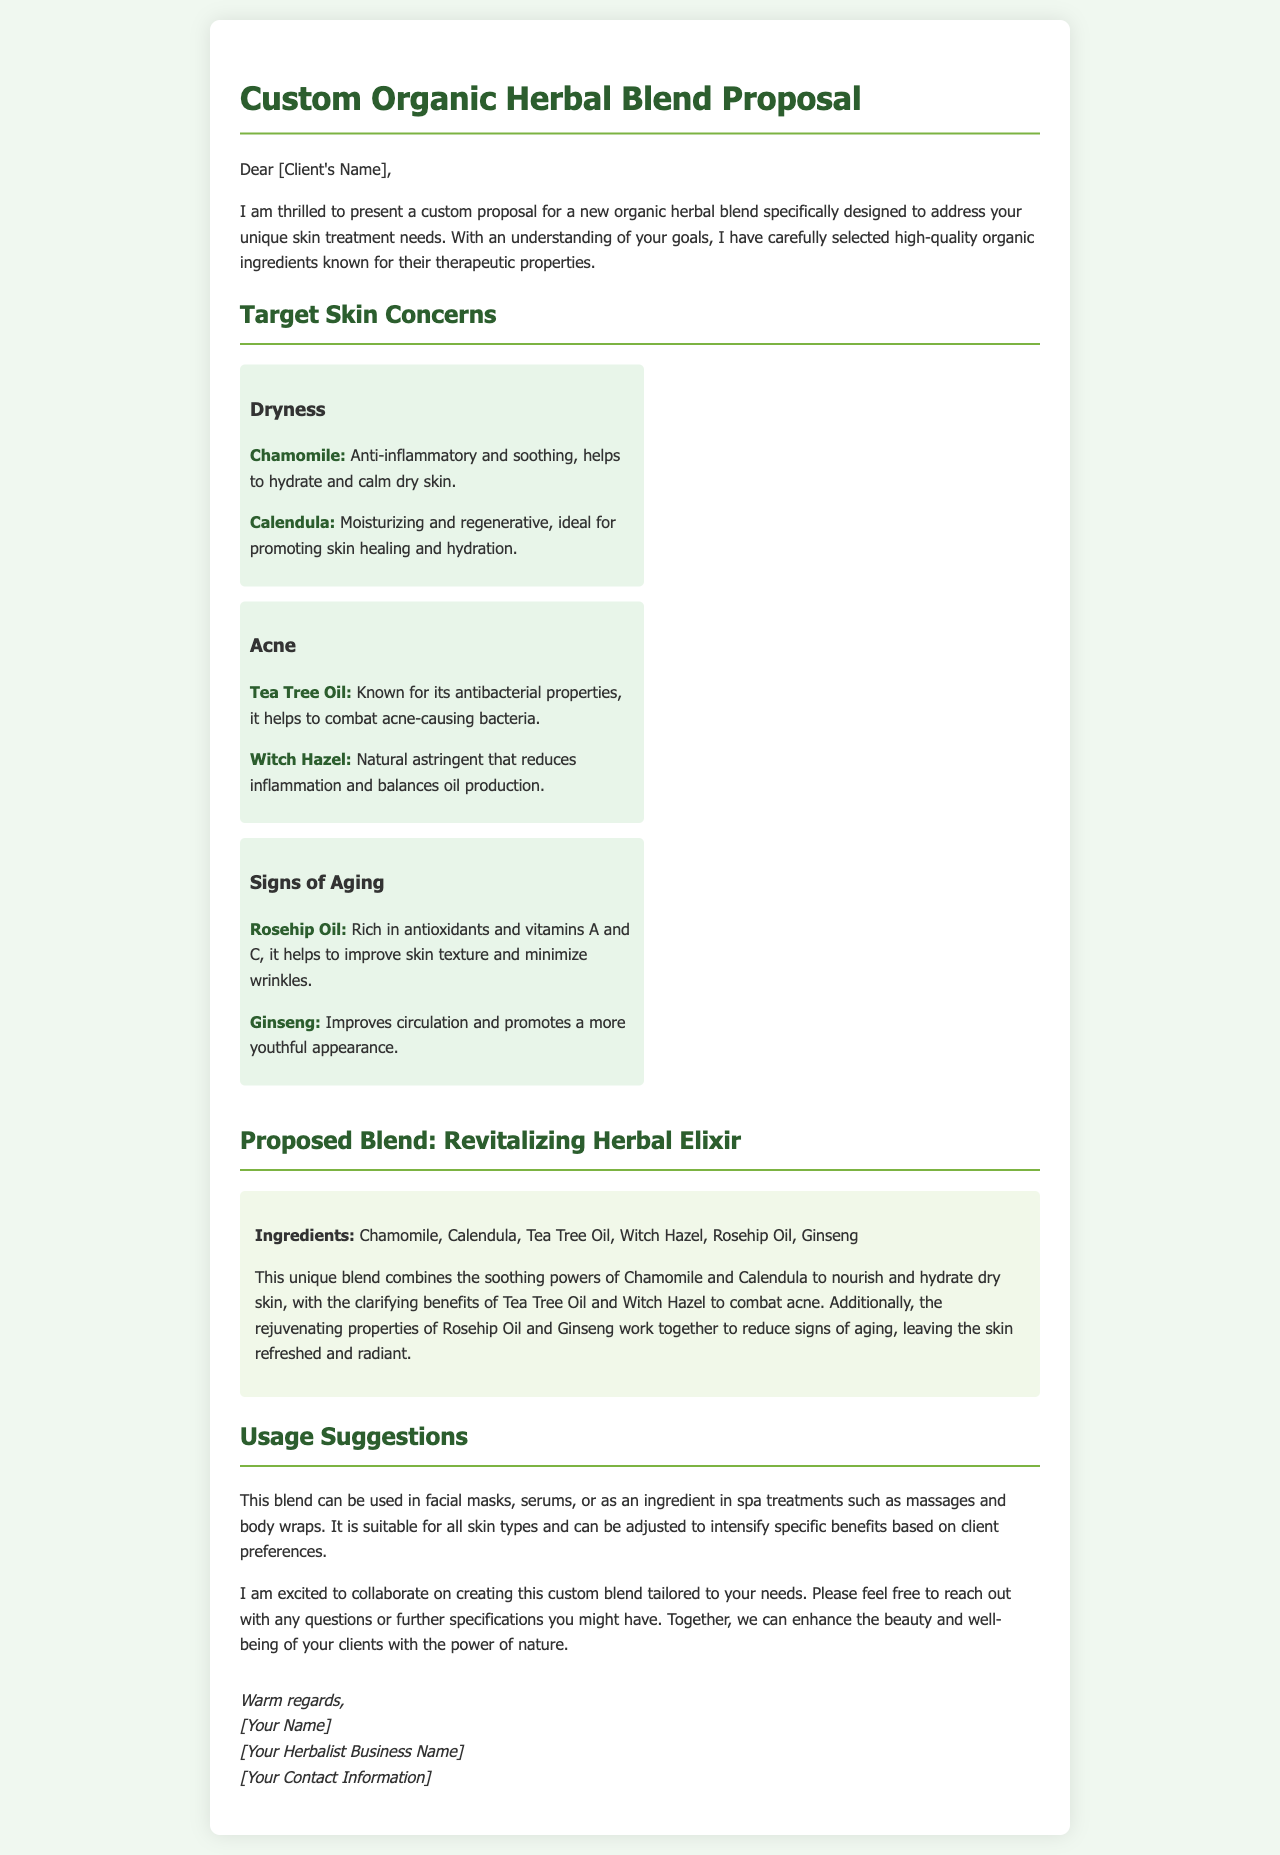What is the title of the proposal? The title of the proposal is presented in the header section of the document.
Answer: Custom Organic Herbal Blend Proposal Who is the target client for this herbal blend? The document starts with an address to the client, indicating the intended recipient.
Answer: [Client's Name] What ingredient is known for its antibacterial properties? The proposal mentions ingredients that target specific skin concerns, including one known for antibacterial properties.
Answer: Tea Tree Oil What skin concern does Witch Hazel address? The document specifies the skin concerns that each herb targets, including the one attributed to Witch Hazel.
Answer: Acne How many ingredients are listed in the proposed blend? The ingredients of the blend are counted within the specific section detailing the blend.
Answer: Six What is the primary benefit of Rosehip Oil mentioned? The document describes the properties of each ingredient, including the primary benefit of Rosehip Oil.
Answer: Improves skin texture What type of treatments can the blend be used in? The usage suggestions section elaborates on how the blend can be applied in various treatments.
Answer: Facial masks, serums, massages, body wraps Who is the author of the proposal? The signature section contains the author's information as listed.
Answer: [Your Name] 